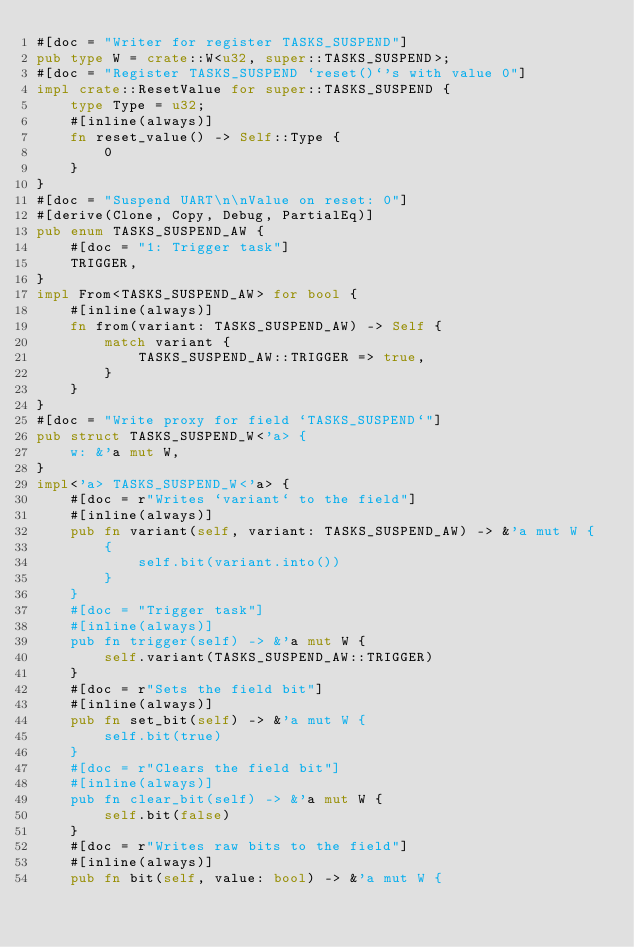<code> <loc_0><loc_0><loc_500><loc_500><_Rust_>#[doc = "Writer for register TASKS_SUSPEND"]
pub type W = crate::W<u32, super::TASKS_SUSPEND>;
#[doc = "Register TASKS_SUSPEND `reset()`'s with value 0"]
impl crate::ResetValue for super::TASKS_SUSPEND {
    type Type = u32;
    #[inline(always)]
    fn reset_value() -> Self::Type {
        0
    }
}
#[doc = "Suspend UART\n\nValue on reset: 0"]
#[derive(Clone, Copy, Debug, PartialEq)]
pub enum TASKS_SUSPEND_AW {
    #[doc = "1: Trigger task"]
    TRIGGER,
}
impl From<TASKS_SUSPEND_AW> for bool {
    #[inline(always)]
    fn from(variant: TASKS_SUSPEND_AW) -> Self {
        match variant {
            TASKS_SUSPEND_AW::TRIGGER => true,
        }
    }
}
#[doc = "Write proxy for field `TASKS_SUSPEND`"]
pub struct TASKS_SUSPEND_W<'a> {
    w: &'a mut W,
}
impl<'a> TASKS_SUSPEND_W<'a> {
    #[doc = r"Writes `variant` to the field"]
    #[inline(always)]
    pub fn variant(self, variant: TASKS_SUSPEND_AW) -> &'a mut W {
        {
            self.bit(variant.into())
        }
    }
    #[doc = "Trigger task"]
    #[inline(always)]
    pub fn trigger(self) -> &'a mut W {
        self.variant(TASKS_SUSPEND_AW::TRIGGER)
    }
    #[doc = r"Sets the field bit"]
    #[inline(always)]
    pub fn set_bit(self) -> &'a mut W {
        self.bit(true)
    }
    #[doc = r"Clears the field bit"]
    #[inline(always)]
    pub fn clear_bit(self) -> &'a mut W {
        self.bit(false)
    }
    #[doc = r"Writes raw bits to the field"]
    #[inline(always)]
    pub fn bit(self, value: bool) -> &'a mut W {</code> 